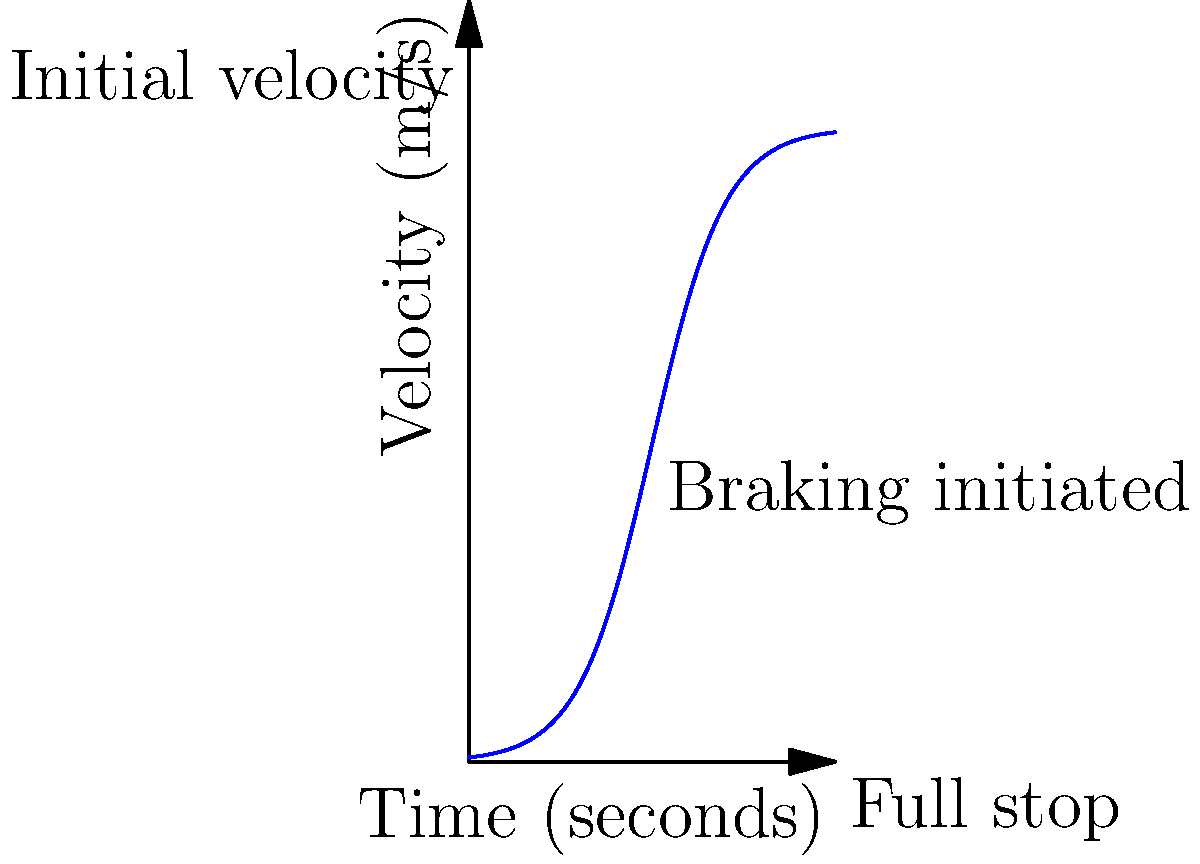As a precision driver, you're preparing for an off-screen contest against your drag racer nemesis. You need to determine the optimal braking distance for your car based on its initial velocity. Given the rate of change graph above, which shows the velocity of your car over time during a braking maneuver, calculate the total distance traveled from the moment you initiate braking until the car comes to a complete stop. Assume the initial velocity is 100 m/s and the braking time is 50 seconds. To solve this problem, we need to follow these steps:

1) The graph represents velocity (v) as a function of time (t). The area under this curve represents the distance traveled.

2) We can approximate the area under the curve using the trapezoidal rule:

   $$\text{Distance} = \frac{1}{2}(v_{\text{initial}} + v_{\text{final}}) \times \text{time}$$

3) From the graph:
   - Initial velocity (v_initial) = 100 m/s
   - Final velocity (v_final) = 0 m/s
   - Time = 50 seconds

4) Plugging these values into the formula:

   $$\text{Distance} = \frac{1}{2}(100 + 0) \times 50$$

5) Simplifying:

   $$\text{Distance} = 50 \times 50 = 2500 \text{ meters}$$

Therefore, the optimal braking distance for the car is approximately 2500 meters.
Answer: 2500 meters 